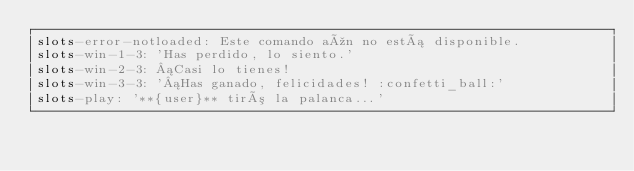<code> <loc_0><loc_0><loc_500><loc_500><_YAML_>slots-error-notloaded: Este comando aún no está disponible.
slots-win-1-3: 'Has perdido, lo siento.'
slots-win-2-3: ¡Casi lo tienes!
slots-win-3-3: '¡Has ganado, felicidades! :confetti_ball:'
slots-play: '**{user}** tiró la palanca...'
</code> 